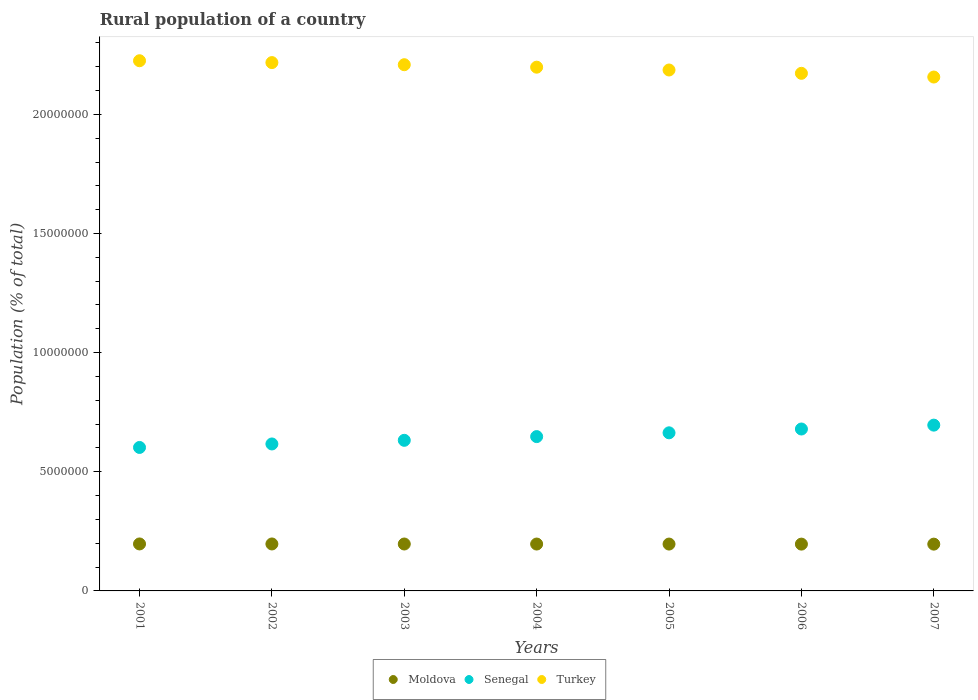How many different coloured dotlines are there?
Give a very brief answer. 3. What is the rural population in Turkey in 2002?
Ensure brevity in your answer.  2.22e+07. Across all years, what is the maximum rural population in Senegal?
Offer a terse response. 6.96e+06. Across all years, what is the minimum rural population in Moldova?
Provide a short and direct response. 1.96e+06. In which year was the rural population in Moldova maximum?
Keep it short and to the point. 2001. What is the total rural population in Senegal in the graph?
Make the answer very short. 4.54e+07. What is the difference between the rural population in Moldova in 2005 and that in 2006?
Your answer should be very brief. 1908. What is the difference between the rural population in Turkey in 2002 and the rural population in Moldova in 2003?
Make the answer very short. 2.02e+07. What is the average rural population in Senegal per year?
Make the answer very short. 6.48e+06. In the year 2005, what is the difference between the rural population in Turkey and rural population in Moldova?
Ensure brevity in your answer.  1.99e+07. What is the ratio of the rural population in Moldova in 2003 to that in 2004?
Provide a succinct answer. 1. Is the rural population in Moldova in 2002 less than that in 2004?
Provide a short and direct response. No. Is the difference between the rural population in Turkey in 2006 and 2007 greater than the difference between the rural population in Moldova in 2006 and 2007?
Provide a short and direct response. Yes. What is the difference between the highest and the second highest rural population in Senegal?
Your response must be concise. 1.62e+05. What is the difference between the highest and the lowest rural population in Turkey?
Provide a succinct answer. 6.84e+05. In how many years, is the rural population in Turkey greater than the average rural population in Turkey taken over all years?
Your answer should be very brief. 4. Is the sum of the rural population in Turkey in 2004 and 2005 greater than the maximum rural population in Senegal across all years?
Give a very brief answer. Yes. Is it the case that in every year, the sum of the rural population in Turkey and rural population in Senegal  is greater than the rural population in Moldova?
Keep it short and to the point. Yes. Does the rural population in Senegal monotonically increase over the years?
Offer a terse response. Yes. Is the rural population in Moldova strictly greater than the rural population in Senegal over the years?
Keep it short and to the point. No. Is the rural population in Moldova strictly less than the rural population in Turkey over the years?
Give a very brief answer. Yes. How many dotlines are there?
Give a very brief answer. 3. How many years are there in the graph?
Your answer should be compact. 7. Does the graph contain grids?
Provide a succinct answer. No. Where does the legend appear in the graph?
Keep it short and to the point. Bottom center. How many legend labels are there?
Give a very brief answer. 3. What is the title of the graph?
Offer a very short reply. Rural population of a country. What is the label or title of the Y-axis?
Make the answer very short. Population (% of total). What is the Population (% of total) in Moldova in 2001?
Offer a very short reply. 1.97e+06. What is the Population (% of total) in Senegal in 2001?
Your response must be concise. 6.02e+06. What is the Population (% of total) of Turkey in 2001?
Your response must be concise. 2.23e+07. What is the Population (% of total) of Moldova in 2002?
Provide a succinct answer. 1.97e+06. What is the Population (% of total) of Senegal in 2002?
Make the answer very short. 6.17e+06. What is the Population (% of total) in Turkey in 2002?
Give a very brief answer. 2.22e+07. What is the Population (% of total) in Moldova in 2003?
Ensure brevity in your answer.  1.97e+06. What is the Population (% of total) in Senegal in 2003?
Offer a very short reply. 6.32e+06. What is the Population (% of total) of Turkey in 2003?
Give a very brief answer. 2.21e+07. What is the Population (% of total) in Moldova in 2004?
Offer a terse response. 1.97e+06. What is the Population (% of total) in Senegal in 2004?
Ensure brevity in your answer.  6.48e+06. What is the Population (% of total) in Turkey in 2004?
Keep it short and to the point. 2.20e+07. What is the Population (% of total) in Moldova in 2005?
Your answer should be very brief. 1.97e+06. What is the Population (% of total) in Senegal in 2005?
Make the answer very short. 6.64e+06. What is the Population (% of total) of Turkey in 2005?
Provide a short and direct response. 2.19e+07. What is the Population (% of total) of Moldova in 2006?
Provide a short and direct response. 1.96e+06. What is the Population (% of total) in Senegal in 2006?
Provide a short and direct response. 6.80e+06. What is the Population (% of total) of Turkey in 2006?
Your response must be concise. 2.17e+07. What is the Population (% of total) of Moldova in 2007?
Your response must be concise. 1.96e+06. What is the Population (% of total) of Senegal in 2007?
Make the answer very short. 6.96e+06. What is the Population (% of total) of Turkey in 2007?
Your answer should be compact. 2.16e+07. Across all years, what is the maximum Population (% of total) in Moldova?
Provide a succinct answer. 1.97e+06. Across all years, what is the maximum Population (% of total) in Senegal?
Make the answer very short. 6.96e+06. Across all years, what is the maximum Population (% of total) of Turkey?
Offer a terse response. 2.23e+07. Across all years, what is the minimum Population (% of total) of Moldova?
Your response must be concise. 1.96e+06. Across all years, what is the minimum Population (% of total) of Senegal?
Ensure brevity in your answer.  6.02e+06. Across all years, what is the minimum Population (% of total) of Turkey?
Your response must be concise. 2.16e+07. What is the total Population (% of total) of Moldova in the graph?
Your answer should be very brief. 1.38e+07. What is the total Population (% of total) in Senegal in the graph?
Keep it short and to the point. 4.54e+07. What is the total Population (% of total) in Turkey in the graph?
Ensure brevity in your answer.  1.54e+08. What is the difference between the Population (% of total) of Moldova in 2001 and that in 2002?
Offer a terse response. 974. What is the difference between the Population (% of total) in Senegal in 2001 and that in 2002?
Make the answer very short. -1.46e+05. What is the difference between the Population (% of total) in Turkey in 2001 and that in 2002?
Provide a short and direct response. 7.75e+04. What is the difference between the Population (% of total) of Moldova in 2001 and that in 2003?
Provide a short and direct response. 2939. What is the difference between the Population (% of total) of Senegal in 2001 and that in 2003?
Offer a terse response. -2.99e+05. What is the difference between the Population (% of total) in Turkey in 2001 and that in 2003?
Your response must be concise. 1.66e+05. What is the difference between the Population (% of total) in Moldova in 2001 and that in 2004?
Your answer should be compact. 4237. What is the difference between the Population (% of total) in Senegal in 2001 and that in 2004?
Your answer should be very brief. -4.56e+05. What is the difference between the Population (% of total) of Turkey in 2001 and that in 2004?
Ensure brevity in your answer.  2.70e+05. What is the difference between the Population (% of total) of Moldova in 2001 and that in 2005?
Make the answer very short. 5459. What is the difference between the Population (% of total) in Senegal in 2001 and that in 2005?
Give a very brief answer. -6.14e+05. What is the difference between the Population (% of total) in Turkey in 2001 and that in 2005?
Your answer should be very brief. 3.88e+05. What is the difference between the Population (% of total) of Moldova in 2001 and that in 2006?
Ensure brevity in your answer.  7367. What is the difference between the Population (% of total) in Senegal in 2001 and that in 2006?
Offer a terse response. -7.74e+05. What is the difference between the Population (% of total) in Turkey in 2001 and that in 2006?
Provide a short and direct response. 5.28e+05. What is the difference between the Population (% of total) of Moldova in 2001 and that in 2007?
Keep it short and to the point. 8373. What is the difference between the Population (% of total) of Senegal in 2001 and that in 2007?
Keep it short and to the point. -9.36e+05. What is the difference between the Population (% of total) of Turkey in 2001 and that in 2007?
Your answer should be compact. 6.84e+05. What is the difference between the Population (% of total) of Moldova in 2002 and that in 2003?
Keep it short and to the point. 1965. What is the difference between the Population (% of total) of Senegal in 2002 and that in 2003?
Keep it short and to the point. -1.53e+05. What is the difference between the Population (% of total) of Turkey in 2002 and that in 2003?
Ensure brevity in your answer.  8.88e+04. What is the difference between the Population (% of total) of Moldova in 2002 and that in 2004?
Provide a succinct answer. 3263. What is the difference between the Population (% of total) of Senegal in 2002 and that in 2004?
Your answer should be very brief. -3.09e+05. What is the difference between the Population (% of total) of Turkey in 2002 and that in 2004?
Provide a short and direct response. 1.93e+05. What is the difference between the Population (% of total) of Moldova in 2002 and that in 2005?
Provide a succinct answer. 4485. What is the difference between the Population (% of total) of Senegal in 2002 and that in 2005?
Make the answer very short. -4.68e+05. What is the difference between the Population (% of total) in Turkey in 2002 and that in 2005?
Give a very brief answer. 3.11e+05. What is the difference between the Population (% of total) in Moldova in 2002 and that in 2006?
Your response must be concise. 6393. What is the difference between the Population (% of total) of Senegal in 2002 and that in 2006?
Ensure brevity in your answer.  -6.28e+05. What is the difference between the Population (% of total) in Turkey in 2002 and that in 2006?
Keep it short and to the point. 4.50e+05. What is the difference between the Population (% of total) of Moldova in 2002 and that in 2007?
Make the answer very short. 7399. What is the difference between the Population (% of total) in Senegal in 2002 and that in 2007?
Make the answer very short. -7.90e+05. What is the difference between the Population (% of total) of Turkey in 2002 and that in 2007?
Your answer should be compact. 6.06e+05. What is the difference between the Population (% of total) in Moldova in 2003 and that in 2004?
Your response must be concise. 1298. What is the difference between the Population (% of total) of Senegal in 2003 and that in 2004?
Give a very brief answer. -1.56e+05. What is the difference between the Population (% of total) in Turkey in 2003 and that in 2004?
Offer a very short reply. 1.04e+05. What is the difference between the Population (% of total) of Moldova in 2003 and that in 2005?
Your answer should be very brief. 2520. What is the difference between the Population (% of total) in Senegal in 2003 and that in 2005?
Offer a very short reply. -3.15e+05. What is the difference between the Population (% of total) in Turkey in 2003 and that in 2005?
Offer a terse response. 2.22e+05. What is the difference between the Population (% of total) in Moldova in 2003 and that in 2006?
Offer a terse response. 4428. What is the difference between the Population (% of total) in Senegal in 2003 and that in 2006?
Provide a succinct answer. -4.75e+05. What is the difference between the Population (% of total) of Turkey in 2003 and that in 2006?
Give a very brief answer. 3.62e+05. What is the difference between the Population (% of total) in Moldova in 2003 and that in 2007?
Provide a succinct answer. 5434. What is the difference between the Population (% of total) of Senegal in 2003 and that in 2007?
Your answer should be compact. -6.37e+05. What is the difference between the Population (% of total) of Turkey in 2003 and that in 2007?
Your answer should be very brief. 5.17e+05. What is the difference between the Population (% of total) of Moldova in 2004 and that in 2005?
Your response must be concise. 1222. What is the difference between the Population (% of total) of Senegal in 2004 and that in 2005?
Your response must be concise. -1.59e+05. What is the difference between the Population (% of total) of Turkey in 2004 and that in 2005?
Ensure brevity in your answer.  1.18e+05. What is the difference between the Population (% of total) of Moldova in 2004 and that in 2006?
Provide a short and direct response. 3130. What is the difference between the Population (% of total) in Senegal in 2004 and that in 2006?
Give a very brief answer. -3.18e+05. What is the difference between the Population (% of total) of Turkey in 2004 and that in 2006?
Your answer should be very brief. 2.58e+05. What is the difference between the Population (% of total) in Moldova in 2004 and that in 2007?
Your answer should be compact. 4136. What is the difference between the Population (% of total) of Senegal in 2004 and that in 2007?
Your answer should be compact. -4.81e+05. What is the difference between the Population (% of total) in Turkey in 2004 and that in 2007?
Your response must be concise. 4.14e+05. What is the difference between the Population (% of total) of Moldova in 2005 and that in 2006?
Give a very brief answer. 1908. What is the difference between the Population (% of total) in Senegal in 2005 and that in 2006?
Keep it short and to the point. -1.60e+05. What is the difference between the Population (% of total) in Turkey in 2005 and that in 2006?
Your answer should be very brief. 1.40e+05. What is the difference between the Population (% of total) of Moldova in 2005 and that in 2007?
Keep it short and to the point. 2914. What is the difference between the Population (% of total) in Senegal in 2005 and that in 2007?
Offer a terse response. -3.22e+05. What is the difference between the Population (% of total) in Turkey in 2005 and that in 2007?
Your response must be concise. 2.95e+05. What is the difference between the Population (% of total) of Moldova in 2006 and that in 2007?
Your answer should be very brief. 1006. What is the difference between the Population (% of total) of Senegal in 2006 and that in 2007?
Make the answer very short. -1.62e+05. What is the difference between the Population (% of total) in Turkey in 2006 and that in 2007?
Offer a terse response. 1.56e+05. What is the difference between the Population (% of total) of Moldova in 2001 and the Population (% of total) of Senegal in 2002?
Keep it short and to the point. -4.20e+06. What is the difference between the Population (% of total) in Moldova in 2001 and the Population (% of total) in Turkey in 2002?
Give a very brief answer. -2.02e+07. What is the difference between the Population (% of total) of Senegal in 2001 and the Population (% of total) of Turkey in 2002?
Your response must be concise. -1.62e+07. What is the difference between the Population (% of total) of Moldova in 2001 and the Population (% of total) of Senegal in 2003?
Provide a short and direct response. -4.35e+06. What is the difference between the Population (% of total) of Moldova in 2001 and the Population (% of total) of Turkey in 2003?
Ensure brevity in your answer.  -2.01e+07. What is the difference between the Population (% of total) of Senegal in 2001 and the Population (% of total) of Turkey in 2003?
Your answer should be compact. -1.61e+07. What is the difference between the Population (% of total) in Moldova in 2001 and the Population (% of total) in Senegal in 2004?
Your answer should be compact. -4.51e+06. What is the difference between the Population (% of total) of Moldova in 2001 and the Population (% of total) of Turkey in 2004?
Ensure brevity in your answer.  -2.00e+07. What is the difference between the Population (% of total) of Senegal in 2001 and the Population (% of total) of Turkey in 2004?
Your answer should be very brief. -1.60e+07. What is the difference between the Population (% of total) in Moldova in 2001 and the Population (% of total) in Senegal in 2005?
Your answer should be compact. -4.66e+06. What is the difference between the Population (% of total) of Moldova in 2001 and the Population (% of total) of Turkey in 2005?
Provide a short and direct response. -1.99e+07. What is the difference between the Population (% of total) in Senegal in 2001 and the Population (% of total) in Turkey in 2005?
Provide a succinct answer. -1.58e+07. What is the difference between the Population (% of total) in Moldova in 2001 and the Population (% of total) in Senegal in 2006?
Ensure brevity in your answer.  -4.82e+06. What is the difference between the Population (% of total) of Moldova in 2001 and the Population (% of total) of Turkey in 2006?
Give a very brief answer. -1.98e+07. What is the difference between the Population (% of total) of Senegal in 2001 and the Population (% of total) of Turkey in 2006?
Provide a short and direct response. -1.57e+07. What is the difference between the Population (% of total) in Moldova in 2001 and the Population (% of total) in Senegal in 2007?
Your answer should be very brief. -4.99e+06. What is the difference between the Population (% of total) of Moldova in 2001 and the Population (% of total) of Turkey in 2007?
Provide a succinct answer. -1.96e+07. What is the difference between the Population (% of total) of Senegal in 2001 and the Population (% of total) of Turkey in 2007?
Ensure brevity in your answer.  -1.55e+07. What is the difference between the Population (% of total) in Moldova in 2002 and the Population (% of total) in Senegal in 2003?
Provide a short and direct response. -4.35e+06. What is the difference between the Population (% of total) of Moldova in 2002 and the Population (% of total) of Turkey in 2003?
Your answer should be very brief. -2.01e+07. What is the difference between the Population (% of total) in Senegal in 2002 and the Population (% of total) in Turkey in 2003?
Give a very brief answer. -1.59e+07. What is the difference between the Population (% of total) of Moldova in 2002 and the Population (% of total) of Senegal in 2004?
Your response must be concise. -4.51e+06. What is the difference between the Population (% of total) of Moldova in 2002 and the Population (% of total) of Turkey in 2004?
Make the answer very short. -2.00e+07. What is the difference between the Population (% of total) in Senegal in 2002 and the Population (% of total) in Turkey in 2004?
Provide a short and direct response. -1.58e+07. What is the difference between the Population (% of total) in Moldova in 2002 and the Population (% of total) in Senegal in 2005?
Your answer should be very brief. -4.66e+06. What is the difference between the Population (% of total) in Moldova in 2002 and the Population (% of total) in Turkey in 2005?
Ensure brevity in your answer.  -1.99e+07. What is the difference between the Population (% of total) in Senegal in 2002 and the Population (% of total) in Turkey in 2005?
Your answer should be compact. -1.57e+07. What is the difference between the Population (% of total) of Moldova in 2002 and the Population (% of total) of Senegal in 2006?
Provide a short and direct response. -4.82e+06. What is the difference between the Population (% of total) in Moldova in 2002 and the Population (% of total) in Turkey in 2006?
Provide a succinct answer. -1.98e+07. What is the difference between the Population (% of total) in Senegal in 2002 and the Population (% of total) in Turkey in 2006?
Your answer should be compact. -1.56e+07. What is the difference between the Population (% of total) of Moldova in 2002 and the Population (% of total) of Senegal in 2007?
Offer a terse response. -4.99e+06. What is the difference between the Population (% of total) of Moldova in 2002 and the Population (% of total) of Turkey in 2007?
Keep it short and to the point. -1.96e+07. What is the difference between the Population (% of total) in Senegal in 2002 and the Population (% of total) in Turkey in 2007?
Keep it short and to the point. -1.54e+07. What is the difference between the Population (% of total) of Moldova in 2003 and the Population (% of total) of Senegal in 2004?
Your answer should be compact. -4.51e+06. What is the difference between the Population (% of total) in Moldova in 2003 and the Population (% of total) in Turkey in 2004?
Give a very brief answer. -2.00e+07. What is the difference between the Population (% of total) in Senegal in 2003 and the Population (% of total) in Turkey in 2004?
Your answer should be compact. -1.57e+07. What is the difference between the Population (% of total) of Moldova in 2003 and the Population (% of total) of Senegal in 2005?
Provide a succinct answer. -4.67e+06. What is the difference between the Population (% of total) of Moldova in 2003 and the Population (% of total) of Turkey in 2005?
Provide a succinct answer. -1.99e+07. What is the difference between the Population (% of total) in Senegal in 2003 and the Population (% of total) in Turkey in 2005?
Provide a short and direct response. -1.55e+07. What is the difference between the Population (% of total) of Moldova in 2003 and the Population (% of total) of Senegal in 2006?
Your answer should be very brief. -4.83e+06. What is the difference between the Population (% of total) of Moldova in 2003 and the Population (% of total) of Turkey in 2006?
Your answer should be very brief. -1.98e+07. What is the difference between the Population (% of total) of Senegal in 2003 and the Population (% of total) of Turkey in 2006?
Offer a very short reply. -1.54e+07. What is the difference between the Population (% of total) in Moldova in 2003 and the Population (% of total) in Senegal in 2007?
Your response must be concise. -4.99e+06. What is the difference between the Population (% of total) in Moldova in 2003 and the Population (% of total) in Turkey in 2007?
Offer a very short reply. -1.96e+07. What is the difference between the Population (% of total) in Senegal in 2003 and the Population (% of total) in Turkey in 2007?
Your answer should be very brief. -1.52e+07. What is the difference between the Population (% of total) of Moldova in 2004 and the Population (% of total) of Senegal in 2005?
Provide a short and direct response. -4.67e+06. What is the difference between the Population (% of total) of Moldova in 2004 and the Population (% of total) of Turkey in 2005?
Your answer should be very brief. -1.99e+07. What is the difference between the Population (% of total) of Senegal in 2004 and the Population (% of total) of Turkey in 2005?
Offer a terse response. -1.54e+07. What is the difference between the Population (% of total) of Moldova in 2004 and the Population (% of total) of Senegal in 2006?
Provide a short and direct response. -4.83e+06. What is the difference between the Population (% of total) in Moldova in 2004 and the Population (% of total) in Turkey in 2006?
Your answer should be compact. -1.98e+07. What is the difference between the Population (% of total) in Senegal in 2004 and the Population (% of total) in Turkey in 2006?
Offer a very short reply. -1.52e+07. What is the difference between the Population (% of total) in Moldova in 2004 and the Population (% of total) in Senegal in 2007?
Offer a terse response. -4.99e+06. What is the difference between the Population (% of total) in Moldova in 2004 and the Population (% of total) in Turkey in 2007?
Keep it short and to the point. -1.96e+07. What is the difference between the Population (% of total) of Senegal in 2004 and the Population (% of total) of Turkey in 2007?
Offer a terse response. -1.51e+07. What is the difference between the Population (% of total) in Moldova in 2005 and the Population (% of total) in Senegal in 2006?
Provide a succinct answer. -4.83e+06. What is the difference between the Population (% of total) in Moldova in 2005 and the Population (% of total) in Turkey in 2006?
Offer a very short reply. -1.98e+07. What is the difference between the Population (% of total) of Senegal in 2005 and the Population (% of total) of Turkey in 2006?
Offer a very short reply. -1.51e+07. What is the difference between the Population (% of total) of Moldova in 2005 and the Population (% of total) of Senegal in 2007?
Your response must be concise. -4.99e+06. What is the difference between the Population (% of total) of Moldova in 2005 and the Population (% of total) of Turkey in 2007?
Your answer should be very brief. -1.96e+07. What is the difference between the Population (% of total) in Senegal in 2005 and the Population (% of total) in Turkey in 2007?
Offer a terse response. -1.49e+07. What is the difference between the Population (% of total) in Moldova in 2006 and the Population (% of total) in Senegal in 2007?
Offer a very short reply. -4.99e+06. What is the difference between the Population (% of total) in Moldova in 2006 and the Population (% of total) in Turkey in 2007?
Provide a succinct answer. -1.96e+07. What is the difference between the Population (% of total) of Senegal in 2006 and the Population (% of total) of Turkey in 2007?
Make the answer very short. -1.48e+07. What is the average Population (% of total) of Moldova per year?
Your response must be concise. 1.97e+06. What is the average Population (% of total) in Senegal per year?
Provide a succinct answer. 6.48e+06. What is the average Population (% of total) of Turkey per year?
Your answer should be very brief. 2.19e+07. In the year 2001, what is the difference between the Population (% of total) of Moldova and Population (% of total) of Senegal?
Offer a terse response. -4.05e+06. In the year 2001, what is the difference between the Population (% of total) in Moldova and Population (% of total) in Turkey?
Offer a terse response. -2.03e+07. In the year 2001, what is the difference between the Population (% of total) in Senegal and Population (% of total) in Turkey?
Your answer should be very brief. -1.62e+07. In the year 2002, what is the difference between the Population (% of total) in Moldova and Population (% of total) in Senegal?
Keep it short and to the point. -4.20e+06. In the year 2002, what is the difference between the Population (% of total) of Moldova and Population (% of total) of Turkey?
Provide a succinct answer. -2.02e+07. In the year 2002, what is the difference between the Population (% of total) in Senegal and Population (% of total) in Turkey?
Give a very brief answer. -1.60e+07. In the year 2003, what is the difference between the Population (% of total) of Moldova and Population (% of total) of Senegal?
Offer a very short reply. -4.35e+06. In the year 2003, what is the difference between the Population (% of total) in Moldova and Population (% of total) in Turkey?
Your response must be concise. -2.01e+07. In the year 2003, what is the difference between the Population (% of total) of Senegal and Population (% of total) of Turkey?
Give a very brief answer. -1.58e+07. In the year 2004, what is the difference between the Population (% of total) of Moldova and Population (% of total) of Senegal?
Offer a terse response. -4.51e+06. In the year 2004, what is the difference between the Population (% of total) of Moldova and Population (% of total) of Turkey?
Provide a succinct answer. -2.00e+07. In the year 2004, what is the difference between the Population (% of total) in Senegal and Population (% of total) in Turkey?
Offer a terse response. -1.55e+07. In the year 2005, what is the difference between the Population (% of total) in Moldova and Population (% of total) in Senegal?
Offer a terse response. -4.67e+06. In the year 2005, what is the difference between the Population (% of total) of Moldova and Population (% of total) of Turkey?
Your answer should be very brief. -1.99e+07. In the year 2005, what is the difference between the Population (% of total) of Senegal and Population (% of total) of Turkey?
Your response must be concise. -1.52e+07. In the year 2006, what is the difference between the Population (% of total) of Moldova and Population (% of total) of Senegal?
Offer a terse response. -4.83e+06. In the year 2006, what is the difference between the Population (% of total) of Moldova and Population (% of total) of Turkey?
Make the answer very short. -1.98e+07. In the year 2006, what is the difference between the Population (% of total) of Senegal and Population (% of total) of Turkey?
Provide a succinct answer. -1.49e+07. In the year 2007, what is the difference between the Population (% of total) of Moldova and Population (% of total) of Senegal?
Ensure brevity in your answer.  -4.99e+06. In the year 2007, what is the difference between the Population (% of total) of Moldova and Population (% of total) of Turkey?
Your answer should be compact. -1.96e+07. In the year 2007, what is the difference between the Population (% of total) of Senegal and Population (% of total) of Turkey?
Offer a very short reply. -1.46e+07. What is the ratio of the Population (% of total) of Senegal in 2001 to that in 2002?
Make the answer very short. 0.98. What is the ratio of the Population (% of total) of Turkey in 2001 to that in 2002?
Keep it short and to the point. 1. What is the ratio of the Population (% of total) in Senegal in 2001 to that in 2003?
Provide a succinct answer. 0.95. What is the ratio of the Population (% of total) in Turkey in 2001 to that in 2003?
Ensure brevity in your answer.  1.01. What is the ratio of the Population (% of total) in Moldova in 2001 to that in 2004?
Give a very brief answer. 1. What is the ratio of the Population (% of total) of Senegal in 2001 to that in 2004?
Keep it short and to the point. 0.93. What is the ratio of the Population (% of total) in Turkey in 2001 to that in 2004?
Give a very brief answer. 1.01. What is the ratio of the Population (% of total) of Moldova in 2001 to that in 2005?
Your answer should be very brief. 1. What is the ratio of the Population (% of total) in Senegal in 2001 to that in 2005?
Your response must be concise. 0.91. What is the ratio of the Population (% of total) of Turkey in 2001 to that in 2005?
Provide a short and direct response. 1.02. What is the ratio of the Population (% of total) of Senegal in 2001 to that in 2006?
Ensure brevity in your answer.  0.89. What is the ratio of the Population (% of total) in Turkey in 2001 to that in 2006?
Make the answer very short. 1.02. What is the ratio of the Population (% of total) in Moldova in 2001 to that in 2007?
Provide a short and direct response. 1. What is the ratio of the Population (% of total) of Senegal in 2001 to that in 2007?
Offer a terse response. 0.87. What is the ratio of the Population (% of total) in Turkey in 2001 to that in 2007?
Keep it short and to the point. 1.03. What is the ratio of the Population (% of total) of Moldova in 2002 to that in 2003?
Provide a succinct answer. 1. What is the ratio of the Population (% of total) in Senegal in 2002 to that in 2003?
Your response must be concise. 0.98. What is the ratio of the Population (% of total) in Senegal in 2002 to that in 2004?
Keep it short and to the point. 0.95. What is the ratio of the Population (% of total) of Turkey in 2002 to that in 2004?
Offer a very short reply. 1.01. What is the ratio of the Population (% of total) of Senegal in 2002 to that in 2005?
Ensure brevity in your answer.  0.93. What is the ratio of the Population (% of total) in Turkey in 2002 to that in 2005?
Offer a terse response. 1.01. What is the ratio of the Population (% of total) of Senegal in 2002 to that in 2006?
Give a very brief answer. 0.91. What is the ratio of the Population (% of total) of Turkey in 2002 to that in 2006?
Offer a terse response. 1.02. What is the ratio of the Population (% of total) in Moldova in 2002 to that in 2007?
Your answer should be compact. 1. What is the ratio of the Population (% of total) of Senegal in 2002 to that in 2007?
Make the answer very short. 0.89. What is the ratio of the Population (% of total) in Turkey in 2002 to that in 2007?
Provide a succinct answer. 1.03. What is the ratio of the Population (% of total) of Senegal in 2003 to that in 2004?
Give a very brief answer. 0.98. What is the ratio of the Population (% of total) in Moldova in 2003 to that in 2005?
Provide a succinct answer. 1. What is the ratio of the Population (% of total) of Senegal in 2003 to that in 2005?
Your answer should be very brief. 0.95. What is the ratio of the Population (% of total) in Turkey in 2003 to that in 2005?
Your answer should be very brief. 1.01. What is the ratio of the Population (% of total) in Senegal in 2003 to that in 2006?
Your answer should be very brief. 0.93. What is the ratio of the Population (% of total) of Turkey in 2003 to that in 2006?
Your answer should be very brief. 1.02. What is the ratio of the Population (% of total) of Moldova in 2003 to that in 2007?
Offer a very short reply. 1. What is the ratio of the Population (% of total) of Senegal in 2003 to that in 2007?
Offer a terse response. 0.91. What is the ratio of the Population (% of total) of Turkey in 2003 to that in 2007?
Your answer should be very brief. 1.02. What is the ratio of the Population (% of total) in Moldova in 2004 to that in 2005?
Your answer should be compact. 1. What is the ratio of the Population (% of total) of Senegal in 2004 to that in 2005?
Your answer should be very brief. 0.98. What is the ratio of the Population (% of total) in Turkey in 2004 to that in 2005?
Offer a terse response. 1.01. What is the ratio of the Population (% of total) of Moldova in 2004 to that in 2006?
Provide a succinct answer. 1. What is the ratio of the Population (% of total) of Senegal in 2004 to that in 2006?
Provide a short and direct response. 0.95. What is the ratio of the Population (% of total) in Turkey in 2004 to that in 2006?
Provide a succinct answer. 1.01. What is the ratio of the Population (% of total) in Moldova in 2004 to that in 2007?
Offer a terse response. 1. What is the ratio of the Population (% of total) in Senegal in 2004 to that in 2007?
Your answer should be compact. 0.93. What is the ratio of the Population (% of total) in Turkey in 2004 to that in 2007?
Give a very brief answer. 1.02. What is the ratio of the Population (% of total) in Senegal in 2005 to that in 2006?
Offer a terse response. 0.98. What is the ratio of the Population (% of total) in Turkey in 2005 to that in 2006?
Your answer should be compact. 1.01. What is the ratio of the Population (% of total) of Moldova in 2005 to that in 2007?
Your answer should be very brief. 1. What is the ratio of the Population (% of total) in Senegal in 2005 to that in 2007?
Give a very brief answer. 0.95. What is the ratio of the Population (% of total) in Turkey in 2005 to that in 2007?
Offer a very short reply. 1.01. What is the ratio of the Population (% of total) in Moldova in 2006 to that in 2007?
Keep it short and to the point. 1. What is the ratio of the Population (% of total) of Senegal in 2006 to that in 2007?
Give a very brief answer. 0.98. What is the difference between the highest and the second highest Population (% of total) in Moldova?
Provide a succinct answer. 974. What is the difference between the highest and the second highest Population (% of total) in Senegal?
Provide a short and direct response. 1.62e+05. What is the difference between the highest and the second highest Population (% of total) of Turkey?
Your response must be concise. 7.75e+04. What is the difference between the highest and the lowest Population (% of total) in Moldova?
Provide a short and direct response. 8373. What is the difference between the highest and the lowest Population (% of total) in Senegal?
Ensure brevity in your answer.  9.36e+05. What is the difference between the highest and the lowest Population (% of total) in Turkey?
Provide a succinct answer. 6.84e+05. 